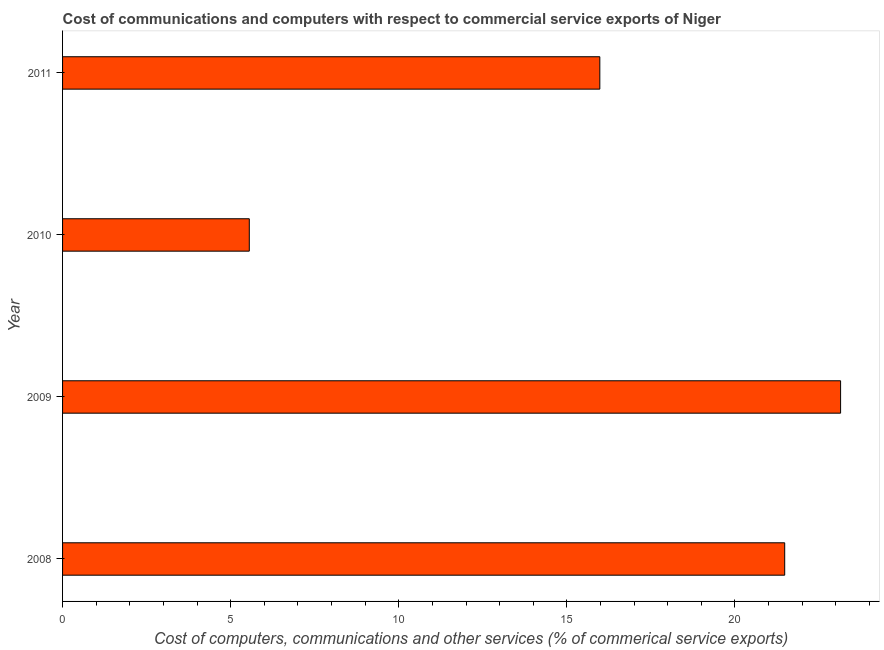Does the graph contain any zero values?
Give a very brief answer. No. Does the graph contain grids?
Your answer should be compact. No. What is the title of the graph?
Give a very brief answer. Cost of communications and computers with respect to commercial service exports of Niger. What is the label or title of the X-axis?
Your answer should be compact. Cost of computers, communications and other services (% of commerical service exports). What is the cost of communications in 2011?
Provide a short and direct response. 15.98. Across all years, what is the maximum cost of communications?
Offer a terse response. 23.14. Across all years, what is the minimum  computer and other services?
Provide a succinct answer. 5.55. In which year was the cost of communications maximum?
Your answer should be compact. 2009. In which year was the cost of communications minimum?
Ensure brevity in your answer.  2010. What is the sum of the cost of communications?
Your answer should be compact. 66.15. What is the difference between the cost of communications in 2008 and 2009?
Offer a very short reply. -1.66. What is the average cost of communications per year?
Make the answer very short. 16.54. What is the median  computer and other services?
Your answer should be very brief. 18.73. Do a majority of the years between 2009 and 2011 (inclusive) have  computer and other services greater than 3 %?
Ensure brevity in your answer.  Yes. What is the ratio of the  computer and other services in 2008 to that in 2011?
Give a very brief answer. 1.34. Is the  computer and other services in 2009 less than that in 2011?
Ensure brevity in your answer.  No. Is the difference between the  computer and other services in 2008 and 2011 greater than the difference between any two years?
Your answer should be compact. No. What is the difference between the highest and the second highest  computer and other services?
Give a very brief answer. 1.66. Is the sum of the  computer and other services in 2010 and 2011 greater than the maximum  computer and other services across all years?
Offer a terse response. No. What is the difference between the highest and the lowest cost of communications?
Make the answer very short. 17.59. In how many years, is the cost of communications greater than the average cost of communications taken over all years?
Your response must be concise. 2. Are all the bars in the graph horizontal?
Make the answer very short. Yes. What is the difference between two consecutive major ticks on the X-axis?
Offer a very short reply. 5. Are the values on the major ticks of X-axis written in scientific E-notation?
Keep it short and to the point. No. What is the Cost of computers, communications and other services (% of commerical service exports) in 2008?
Your answer should be compact. 21.48. What is the Cost of computers, communications and other services (% of commerical service exports) of 2009?
Your answer should be very brief. 23.14. What is the Cost of computers, communications and other services (% of commerical service exports) in 2010?
Give a very brief answer. 5.55. What is the Cost of computers, communications and other services (% of commerical service exports) in 2011?
Offer a very short reply. 15.98. What is the difference between the Cost of computers, communications and other services (% of commerical service exports) in 2008 and 2009?
Ensure brevity in your answer.  -1.66. What is the difference between the Cost of computers, communications and other services (% of commerical service exports) in 2008 and 2010?
Keep it short and to the point. 15.93. What is the difference between the Cost of computers, communications and other services (% of commerical service exports) in 2008 and 2011?
Make the answer very short. 5.5. What is the difference between the Cost of computers, communications and other services (% of commerical service exports) in 2009 and 2010?
Ensure brevity in your answer.  17.59. What is the difference between the Cost of computers, communications and other services (% of commerical service exports) in 2009 and 2011?
Your response must be concise. 7.16. What is the difference between the Cost of computers, communications and other services (% of commerical service exports) in 2010 and 2011?
Offer a very short reply. -10.43. What is the ratio of the Cost of computers, communications and other services (% of commerical service exports) in 2008 to that in 2009?
Offer a terse response. 0.93. What is the ratio of the Cost of computers, communications and other services (% of commerical service exports) in 2008 to that in 2010?
Keep it short and to the point. 3.87. What is the ratio of the Cost of computers, communications and other services (% of commerical service exports) in 2008 to that in 2011?
Ensure brevity in your answer.  1.34. What is the ratio of the Cost of computers, communications and other services (% of commerical service exports) in 2009 to that in 2010?
Offer a very short reply. 4.17. What is the ratio of the Cost of computers, communications and other services (% of commerical service exports) in 2009 to that in 2011?
Your response must be concise. 1.45. What is the ratio of the Cost of computers, communications and other services (% of commerical service exports) in 2010 to that in 2011?
Offer a terse response. 0.35. 